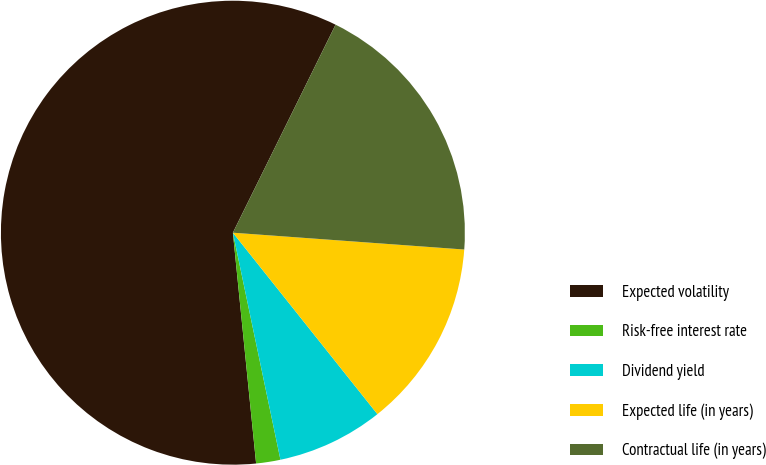<chart> <loc_0><loc_0><loc_500><loc_500><pie_chart><fcel>Expected volatility<fcel>Risk-free interest rate<fcel>Dividend yield<fcel>Expected life (in years)<fcel>Contractual life (in years)<nl><fcel>58.9%<fcel>1.69%<fcel>7.42%<fcel>13.14%<fcel>18.86%<nl></chart> 